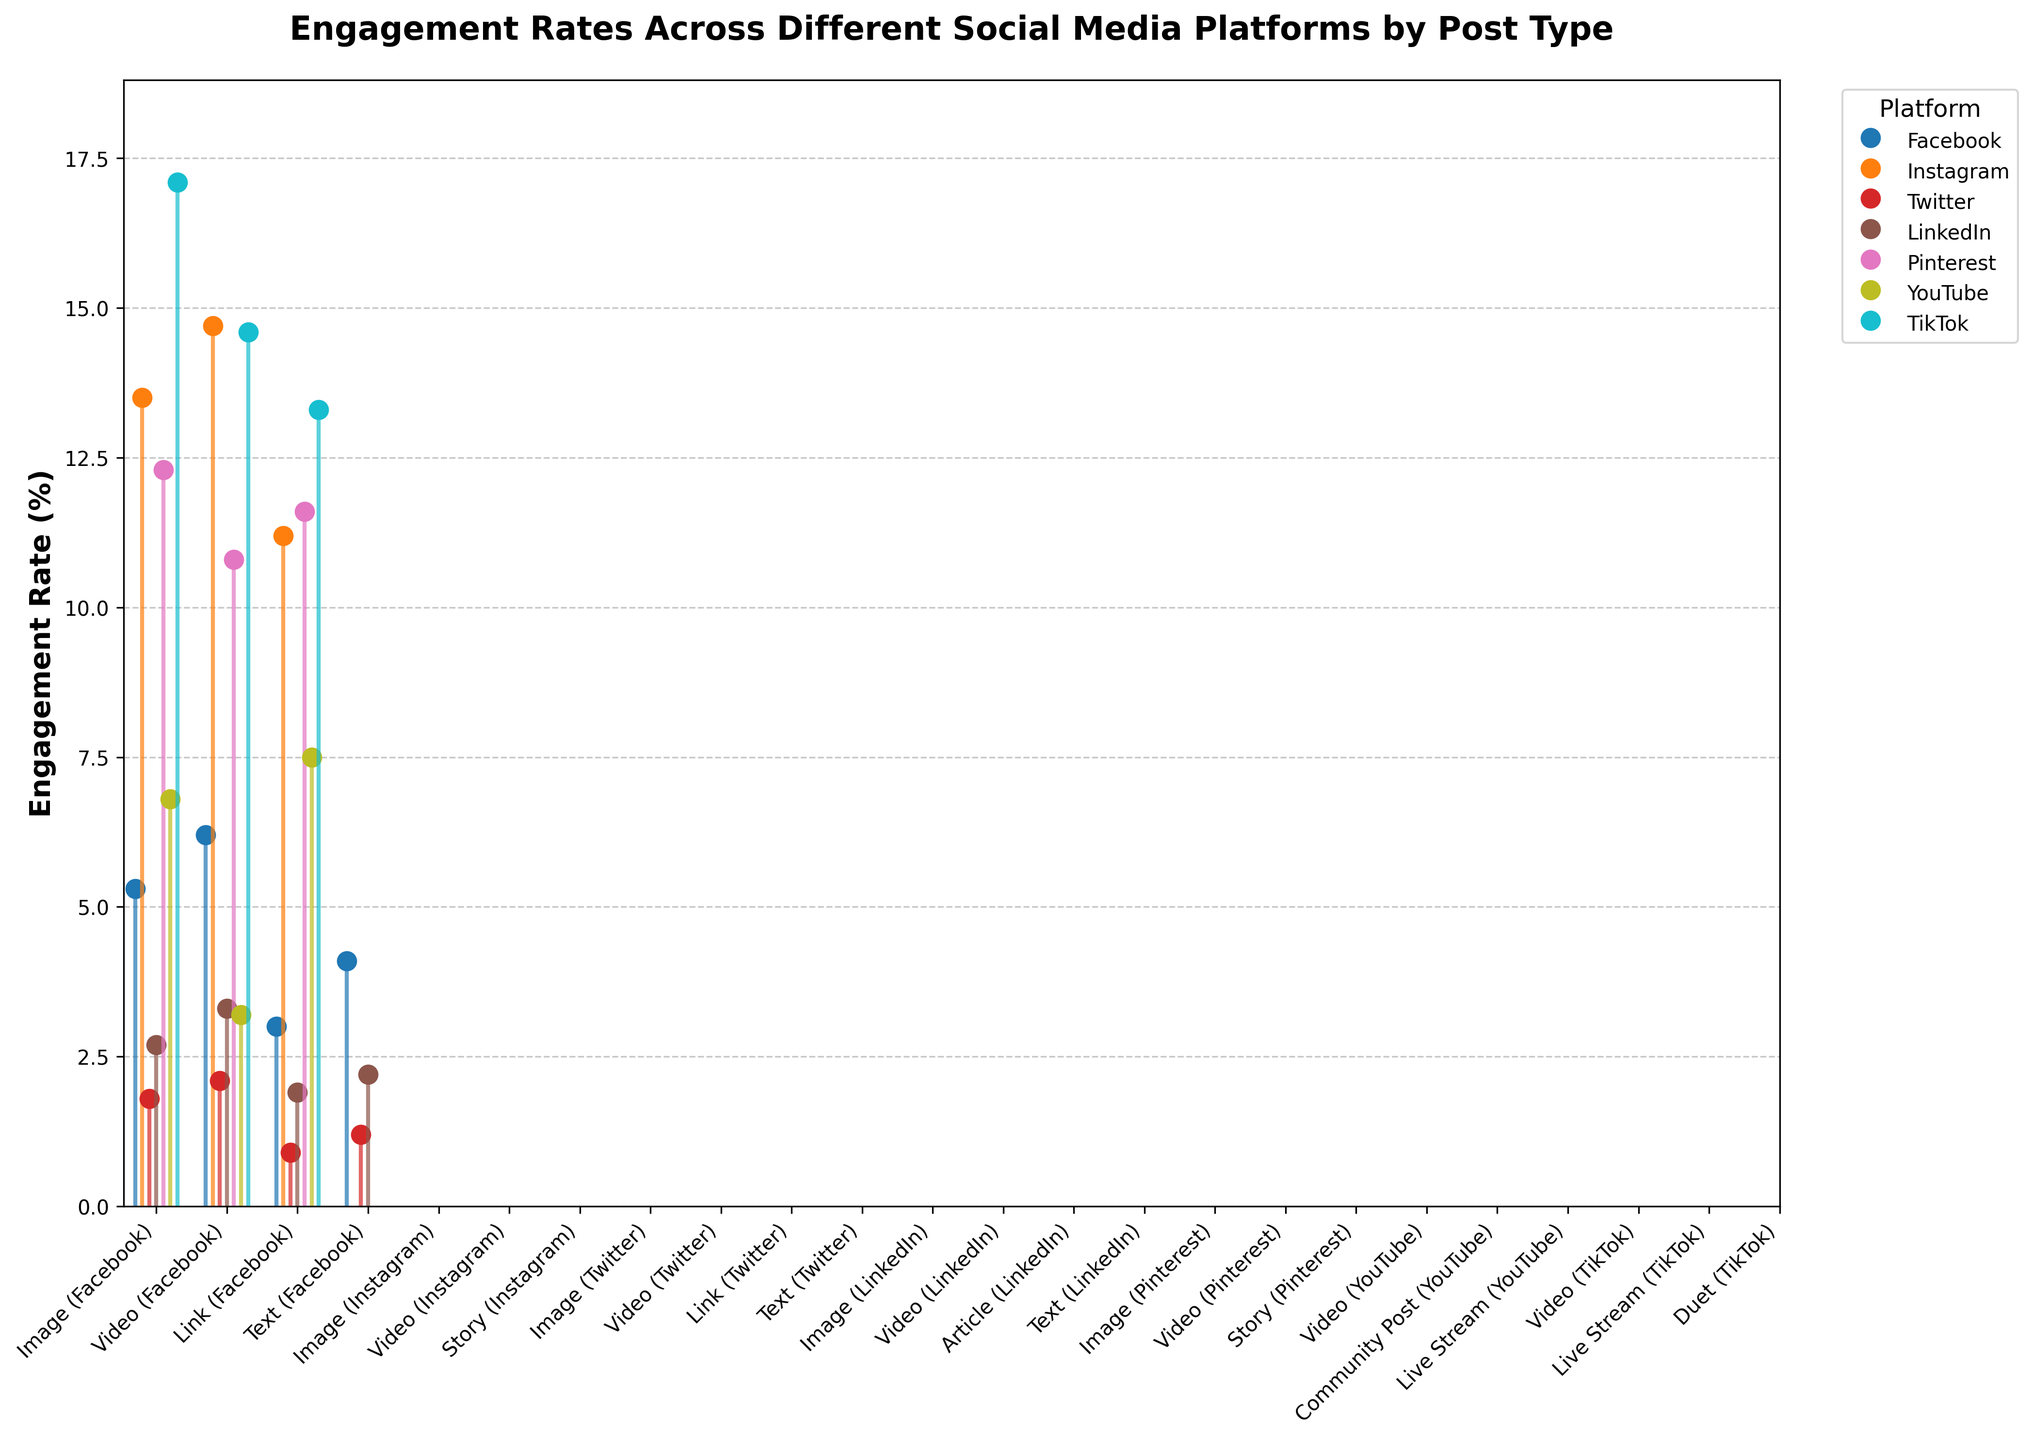What is the title of the plot? The title of the plot is typically displayed at the top of the figure. In this case, it reads "Engagement Rates Across Different Social Media Platforms by Post Type".
Answer: Engagement Rates Across Different Social Media Platforms by Post Type Which social media platform has the highest engagement rate and what is that rate? To determine this, visually inspect the tallest stem in the plot. TikTok shows the highest engagement rate with its Video post type reaching 17.1%.
Answer: TikTok, 17.1% How do Facebook's Image and LinkedIn's Video engagement rates compare? Locate the stems corresponding to Facebook's Image and LinkedIn's Video post types. Facebook's Image post type has a 5.3% engagement rate, while LinkedIn's Video has a 3.3% engagement rate.
Answer: Facebook's Image is higher by 2.0% What is the average engagement rate of Instagram's post types? Add the engagement rates for Instagram's Image (13.5%), Video (14.7%), and Story (11.2%) and divide by the number of post types (3). The calculation is (13.5 + 14.7 + 11.2) / 3.
Answer: 13.1% For Pinterest, which post type has the lowest engagement rate? Examine the stems for Pinterest's post types. The engagement rates are Video (10.8%), Image (12.3%), and Story (11.6%). The lowest rate is the Video post type.
Answer: Video Between Twitter's Text and Link post types, which has a higher engagement rate and by how much? Find the stems for Twitter's Text (1.2%) and Link (0.9%) post types. Twitter's Text has a higher engagement rate by 0.3%.
Answer: Text, 0.3% Are there any post types in the plot with an engagement rate above 15%? Scan the plot for any stems that exceed the 15% mark. TikTok's Video post type stands out with 17.1% engagement.
Answer: Yes, TikTok Video Compare the engagement rates of YouTube's Video and Live Stream post types. Locate the stems for YouTube’s Video (6.8%) and Live Stream (7.5%) post types. The engagement rate for Live Stream is higher by 0.7%.
Answer: Live Stream, 0.7% Which platform has the most post types represented in the plot? Count the distinct post types for each platform. Both Facebook and TikTok have four distinct post types in the figure.
Answer: Facebook and TikTok 